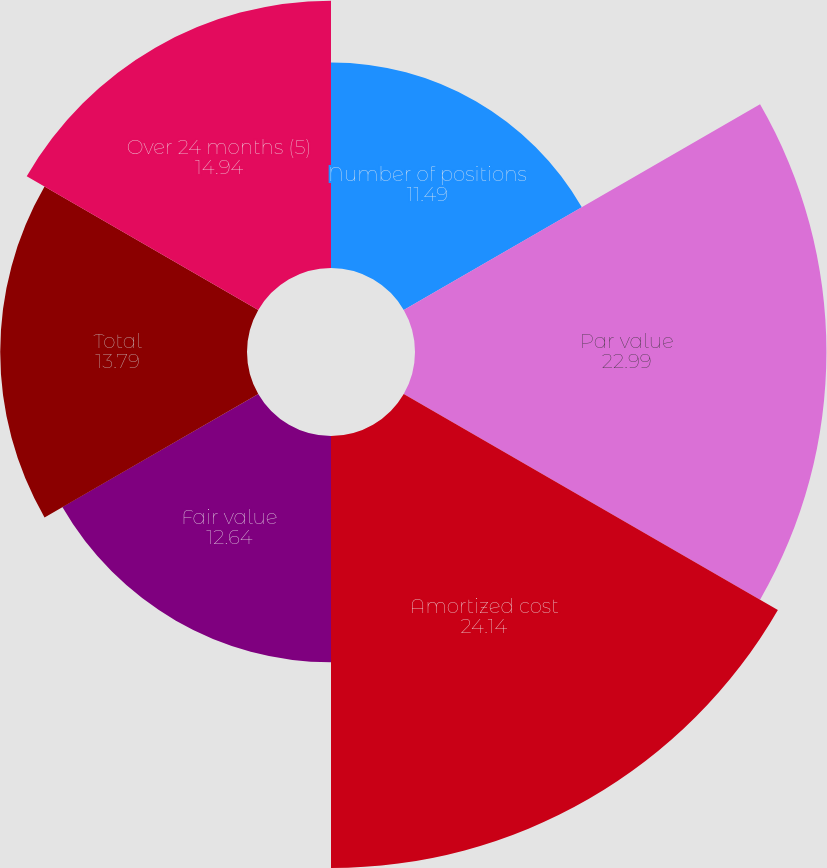Convert chart to OTSL. <chart><loc_0><loc_0><loc_500><loc_500><pie_chart><fcel>Number of positions<fcel>Par value<fcel>Amortized cost<fcel>Fair value<fcel>Total<fcel>Over 24 months (5)<nl><fcel>11.49%<fcel>22.99%<fcel>24.14%<fcel>12.64%<fcel>13.79%<fcel>14.94%<nl></chart> 